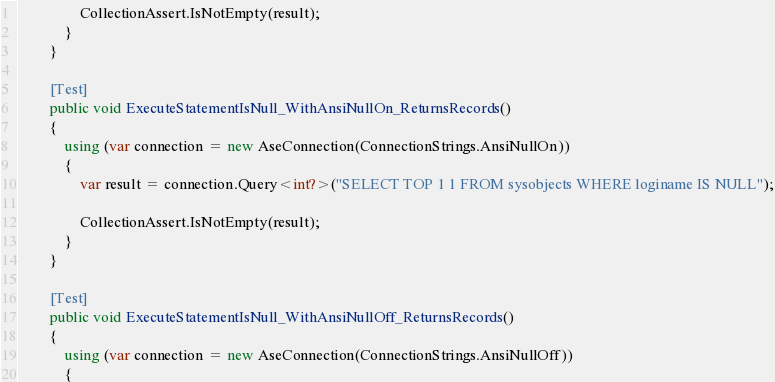<code> <loc_0><loc_0><loc_500><loc_500><_C#_>                CollectionAssert.IsNotEmpty(result);
            }
        }

        [Test]
        public void ExecuteStatementIsNull_WithAnsiNullOn_ReturnsRecords()
        {
            using (var connection = new AseConnection(ConnectionStrings.AnsiNullOn))
            {
                var result = connection.Query<int?>("SELECT TOP 1 1 FROM sysobjects WHERE loginame IS NULL");

                CollectionAssert.IsNotEmpty(result);
            }
        }

        [Test]
        public void ExecuteStatementIsNull_WithAnsiNullOff_ReturnsRecords()
        {
            using (var connection = new AseConnection(ConnectionStrings.AnsiNullOff))
            {</code> 